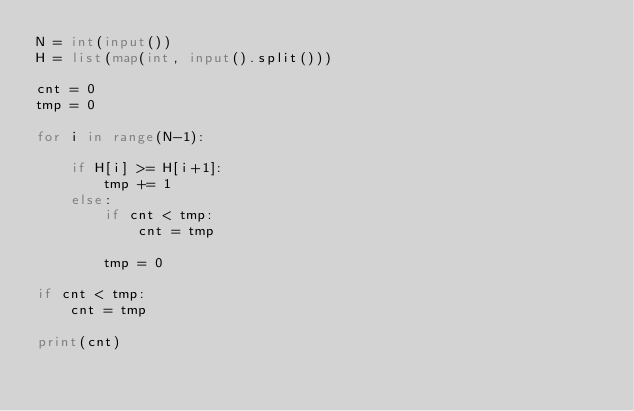Convert code to text. <code><loc_0><loc_0><loc_500><loc_500><_Python_>N = int(input())
H = list(map(int, input().split()))

cnt = 0
tmp = 0

for i in range(N-1):

    if H[i] >= H[i+1]:
        tmp += 1
    else:
        if cnt < tmp:
            cnt = tmp
        
        tmp = 0

if cnt < tmp:
    cnt = tmp

print(cnt)
</code> 